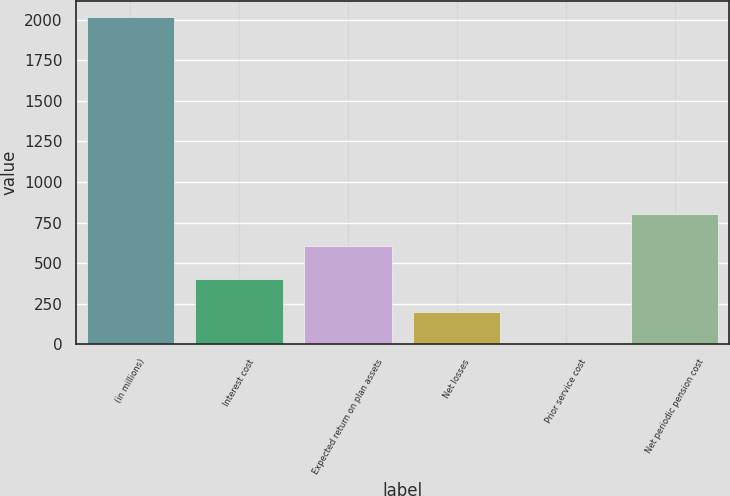Convert chart to OTSL. <chart><loc_0><loc_0><loc_500><loc_500><bar_chart><fcel>(in millions)<fcel>Interest cost<fcel>Expected return on plan assets<fcel>Net losses<fcel>Prior service cost<fcel>Net periodic pension cost<nl><fcel>2013<fcel>403.4<fcel>604.6<fcel>202.2<fcel>1<fcel>805.8<nl></chart> 